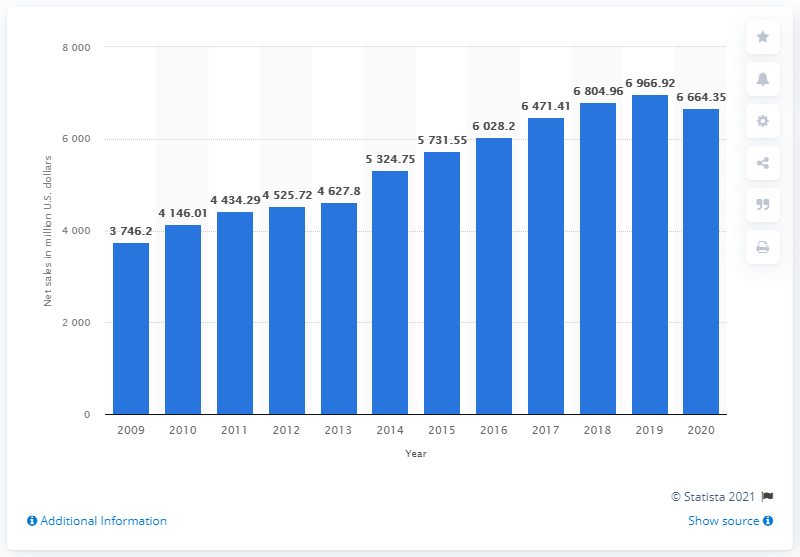Specify some key components in this picture. Hanesbrands' net sales in dollars in 2020 were 66,643.50. 